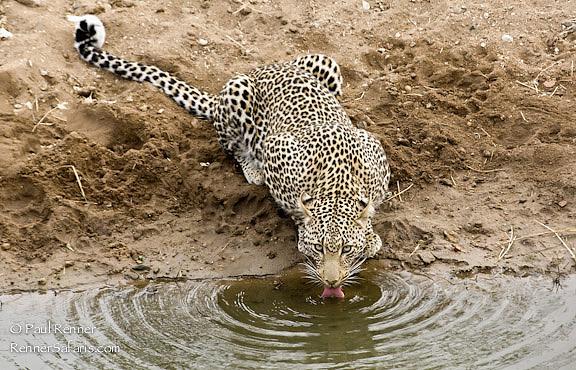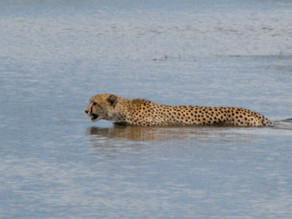The first image is the image on the left, the second image is the image on the right. Analyze the images presented: Is the assertion "Each image features one spotted wildcat and a body of water, and in one image, the cat is actually drinking at the edge of the water." valid? Answer yes or no. Yes. The first image is the image on the left, the second image is the image on the right. Given the left and right images, does the statement "The left image contains one cheetah standing on the bank of a lake drinking water." hold true? Answer yes or no. Yes. 